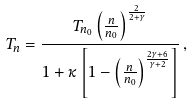<formula> <loc_0><loc_0><loc_500><loc_500>T _ { n } = \frac { T _ { n _ { 0 } } \left ( \frac { n } { n _ { 0 } } \right ) ^ { \frac { 2 } { 2 + \gamma } } } { 1 + \kappa \left [ 1 - \left ( \frac { n } { n _ { 0 } } \right ) ^ { \frac { 2 \gamma + 6 } { \gamma + 2 } } \right ] } \, ,</formula> 